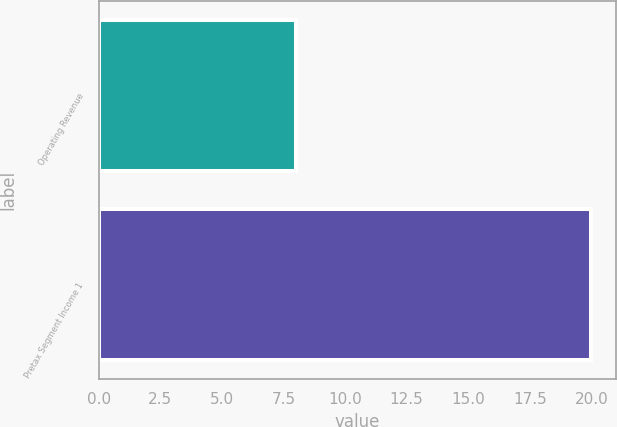Convert chart. <chart><loc_0><loc_0><loc_500><loc_500><bar_chart><fcel>Operating Revenue<fcel>Pretax Segment Income 1<nl><fcel>8<fcel>20<nl></chart> 